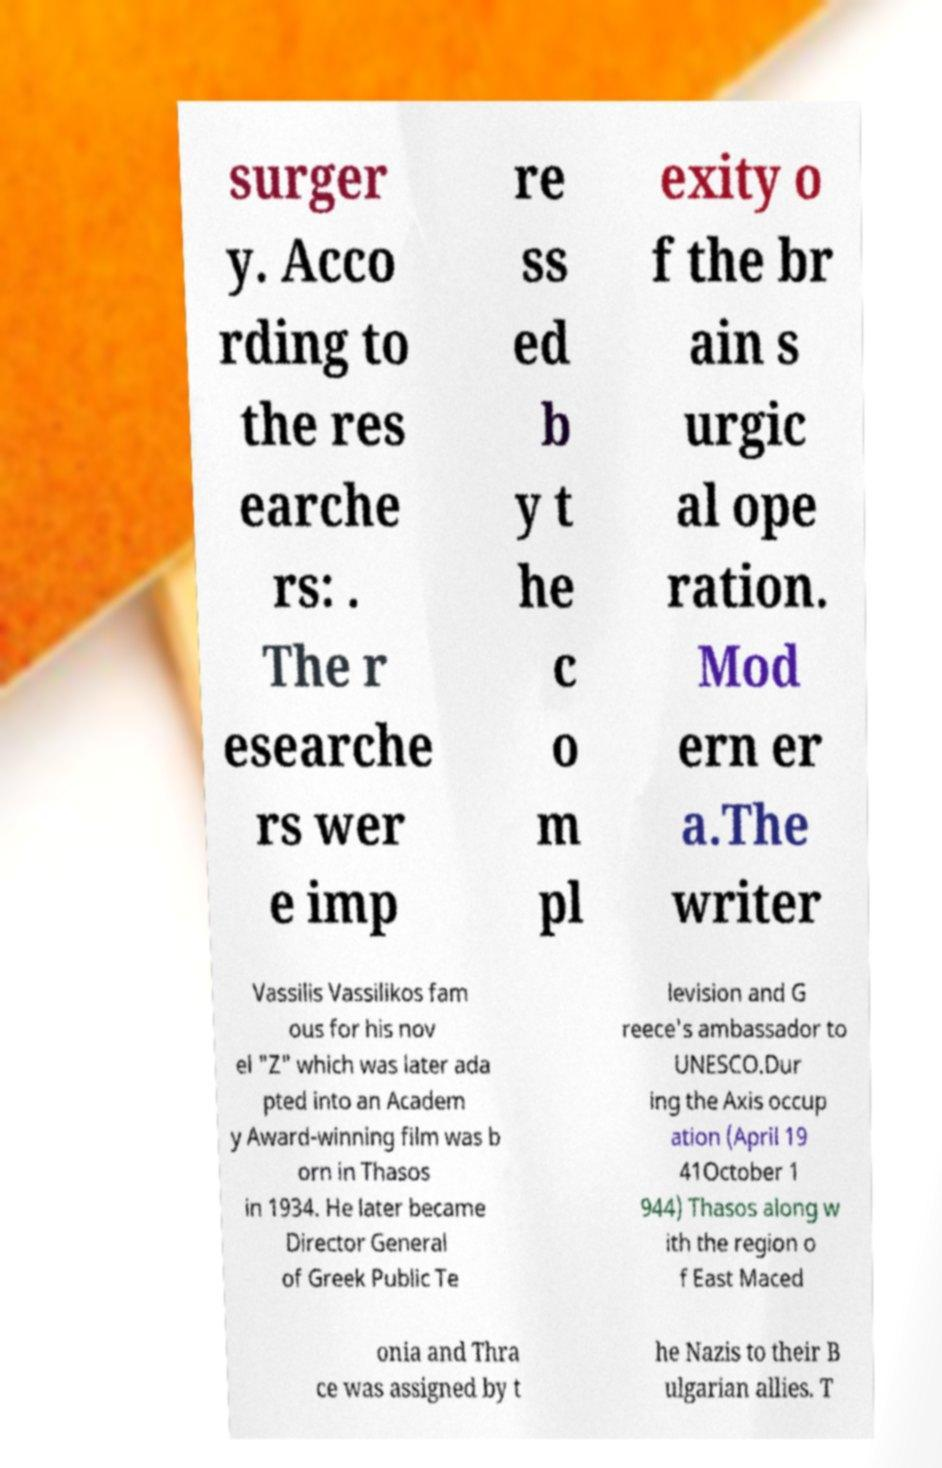Please read and relay the text visible in this image. What does it say? surger y. Acco rding to the res earche rs: . The r esearche rs wer e imp re ss ed b y t he c o m pl exity o f the br ain s urgic al ope ration. Mod ern er a.The writer Vassilis Vassilikos fam ous for his nov el "Z" which was later ada pted into an Academ y Award-winning film was b orn in Thasos in 1934. He later became Director General of Greek Public Te levision and G reece's ambassador to UNESCO.Dur ing the Axis occup ation (April 19 41October 1 944) Thasos along w ith the region o f East Maced onia and Thra ce was assigned by t he Nazis to their B ulgarian allies. T 